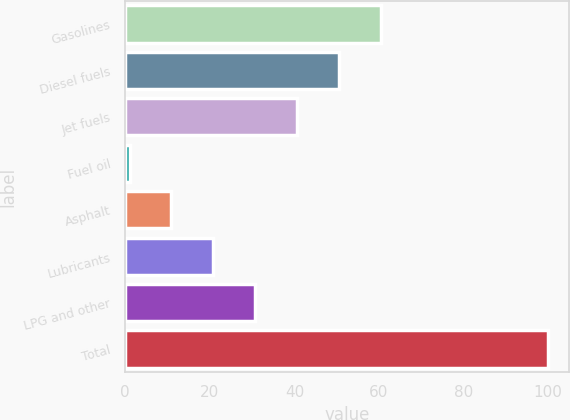Convert chart. <chart><loc_0><loc_0><loc_500><loc_500><bar_chart><fcel>Gasolines<fcel>Diesel fuels<fcel>Jet fuels<fcel>Fuel oil<fcel>Asphalt<fcel>Lubricants<fcel>LPG and other<fcel>Total<nl><fcel>60.4<fcel>50.5<fcel>40.6<fcel>1<fcel>10.9<fcel>20.8<fcel>30.7<fcel>100<nl></chart> 